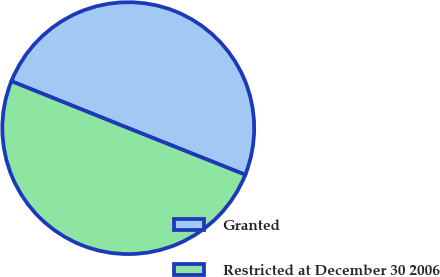<chart> <loc_0><loc_0><loc_500><loc_500><pie_chart><fcel>Granted<fcel>Restricted at December 30 2006<nl><fcel>49.96%<fcel>50.04%<nl></chart> 